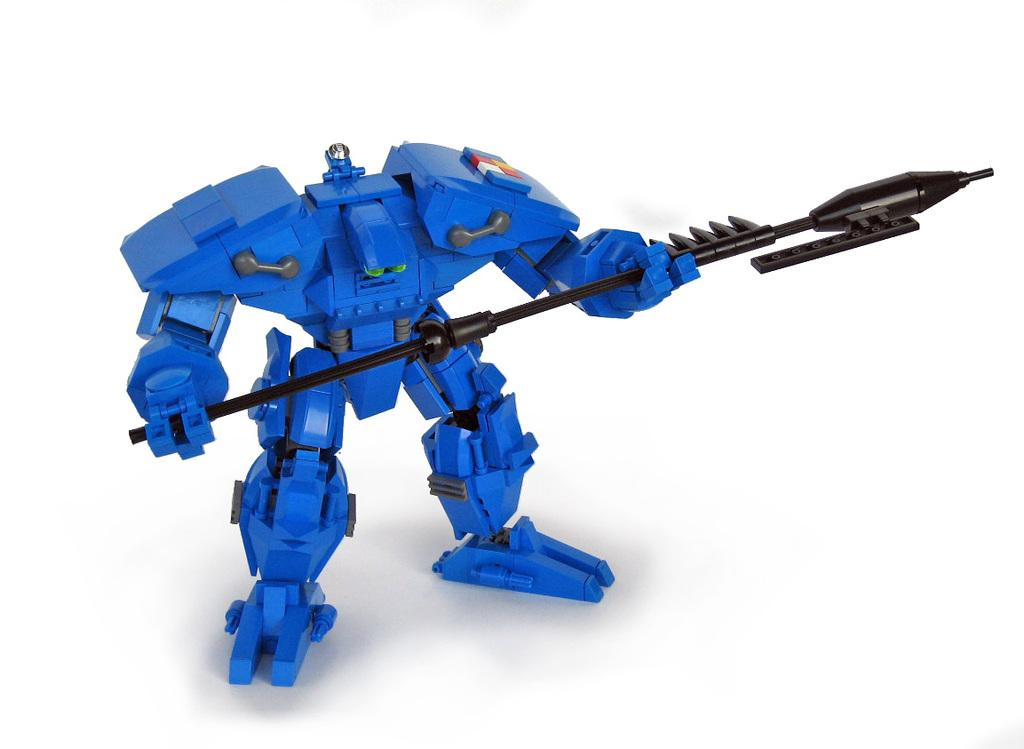What type of toy is present in the image? There is a blue colored robot toy in the image. What is the robot toy holding? The robot toy is holding a spade. What type of cloth is draped over the robot toy in the image? There is no cloth draped over the robot toy in the image. Can you tell me how the robot toy is helping in the cemetery in the image? There is no cemetery present in the image, and the robot toy is not performing any tasks related to a cemetery. 